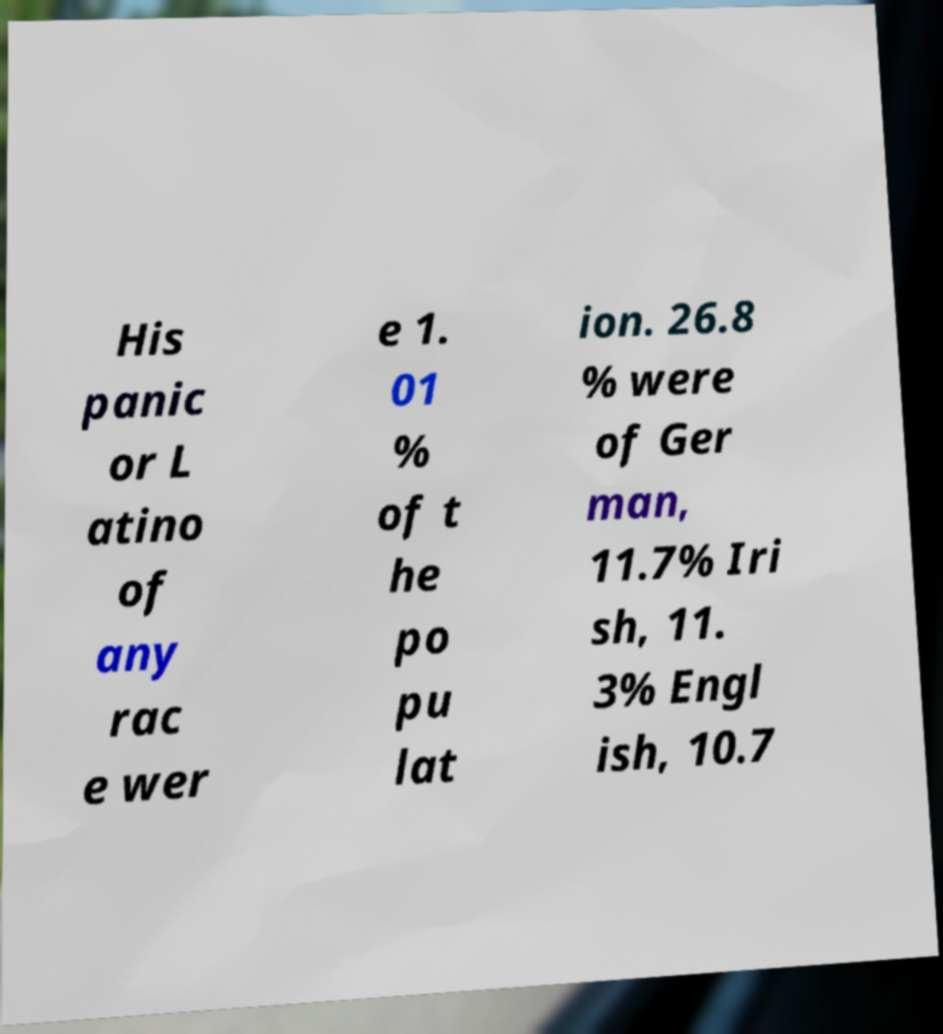Please read and relay the text visible in this image. What does it say? His panic or L atino of any rac e wer e 1. 01 % of t he po pu lat ion. 26.8 % were of Ger man, 11.7% Iri sh, 11. 3% Engl ish, 10.7 